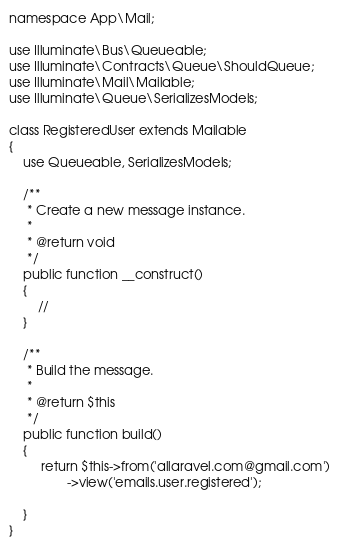Convert code to text. <code><loc_0><loc_0><loc_500><loc_500><_PHP_>namespace App\Mail;

use Illuminate\Bus\Queueable;
use Illuminate\Contracts\Queue\ShouldQueue;
use Illuminate\Mail\Mailable;
use Illuminate\Queue\SerializesModels;

class RegisteredUser extends Mailable
{
    use Queueable, SerializesModels;

    /**
     * Create a new message instance.
     *
     * @return void
     */
    public function __construct()
    {
        //
    }

    /**
     * Build the message.
     *
     * @return $this
     */
    public function build()
    {
         return $this->from('allaravel.com@gmail.com')
                ->view('emails.user.registered');

    }
}
</code> 